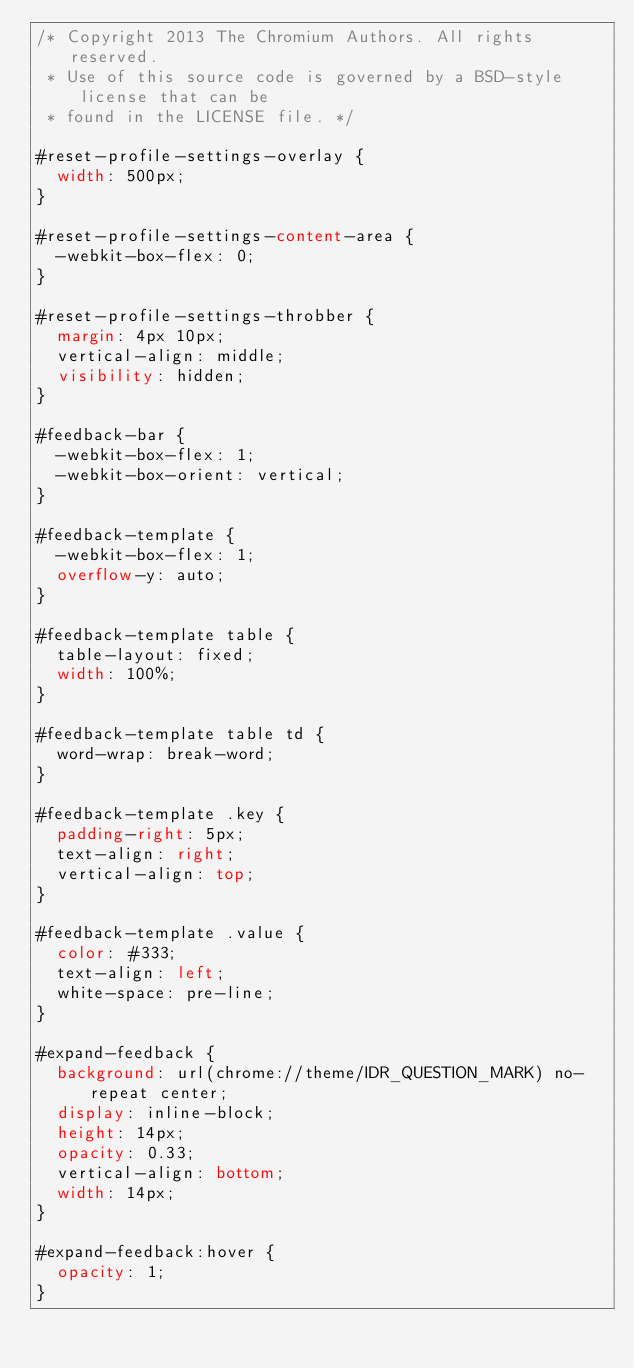<code> <loc_0><loc_0><loc_500><loc_500><_CSS_>/* Copyright 2013 The Chromium Authors. All rights reserved.
 * Use of this source code is governed by a BSD-style license that can be
 * found in the LICENSE file. */

#reset-profile-settings-overlay {
  width: 500px;
}

#reset-profile-settings-content-area {
  -webkit-box-flex: 0;
}

#reset-profile-settings-throbber {
  margin: 4px 10px;
  vertical-align: middle;
  visibility: hidden;
}

#feedback-bar {
  -webkit-box-flex: 1;
  -webkit-box-orient: vertical;
}

#feedback-template {
  -webkit-box-flex: 1;
  overflow-y: auto;
}

#feedback-template table {
  table-layout: fixed;
  width: 100%;
}

#feedback-template table td {
  word-wrap: break-word;
}

#feedback-template .key {
  padding-right: 5px;
  text-align: right;
  vertical-align: top;
}

#feedback-template .value {
  color: #333;
  text-align: left;
  white-space: pre-line;
}

#expand-feedback {
  background: url(chrome://theme/IDR_QUESTION_MARK) no-repeat center;
  display: inline-block;
  height: 14px;
  opacity: 0.33;
  vertical-align: bottom;
  width: 14px;
}

#expand-feedback:hover {
  opacity: 1;
}
</code> 